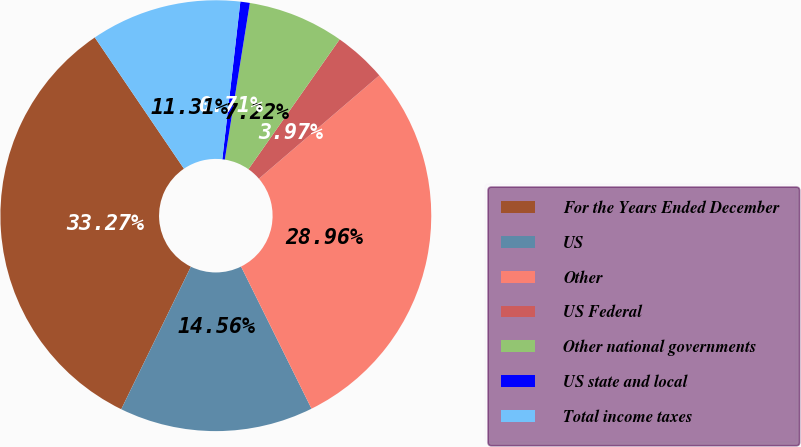Convert chart to OTSL. <chart><loc_0><loc_0><loc_500><loc_500><pie_chart><fcel>For the Years Ended December<fcel>US<fcel>Other<fcel>US Federal<fcel>Other national governments<fcel>US state and local<fcel>Total income taxes<nl><fcel>33.27%<fcel>14.56%<fcel>28.96%<fcel>3.97%<fcel>7.22%<fcel>0.71%<fcel>11.31%<nl></chart> 